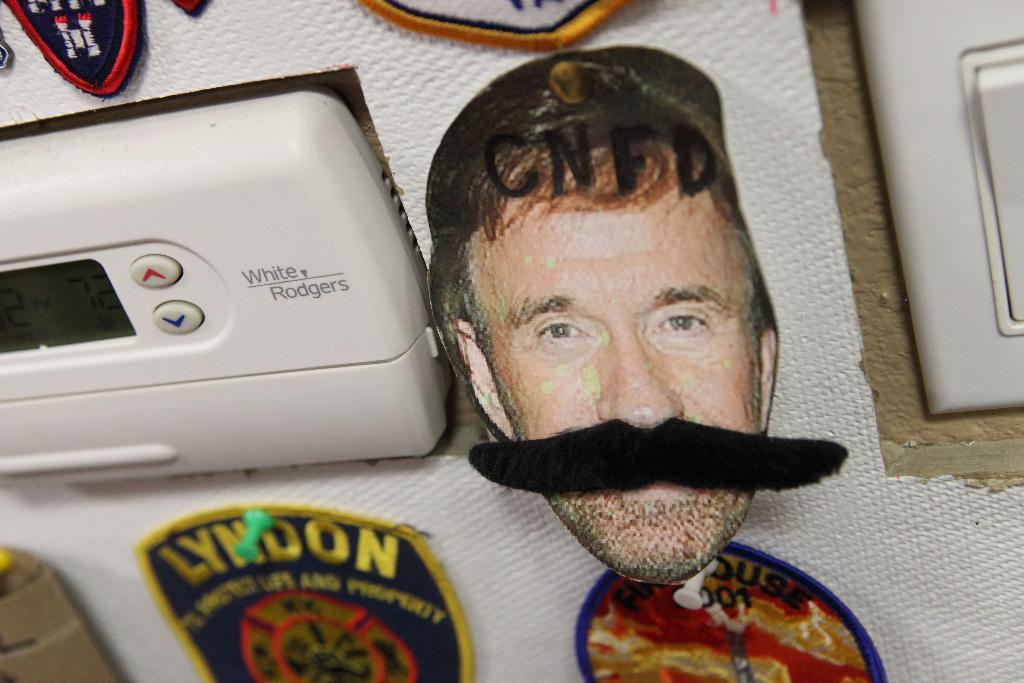What brand of thermostat is on the wall?
Your response must be concise. White rodgers. What does the badge to the bottom left say?
Your answer should be very brief. Lyndon. 